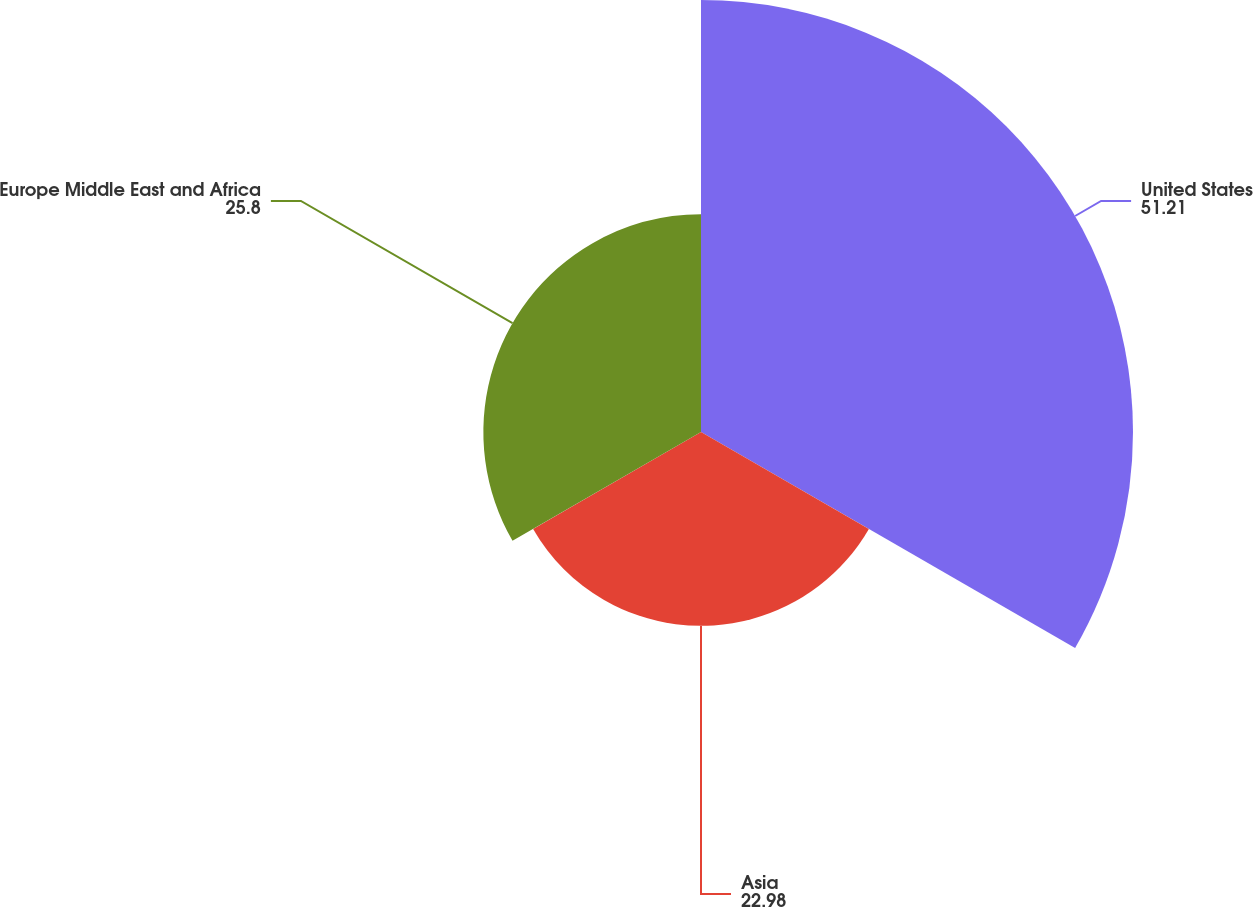Convert chart to OTSL. <chart><loc_0><loc_0><loc_500><loc_500><pie_chart><fcel>United States<fcel>Asia<fcel>Europe Middle East and Africa<nl><fcel>51.21%<fcel>22.98%<fcel>25.8%<nl></chart> 